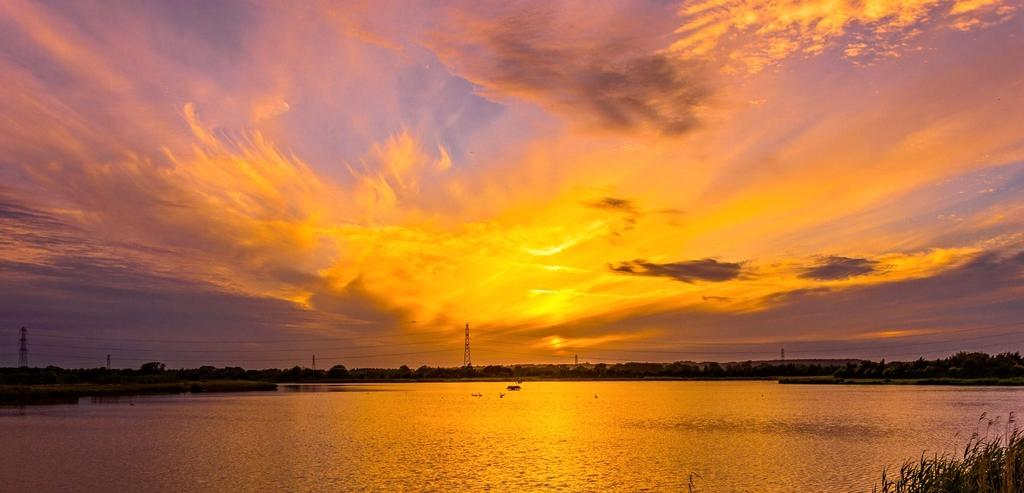What is the primary element present in the image? There is water in the image. What type of natural elements can be seen in the image? There are trees in the image. What man-made structures are visible in the image? There are poles and a building in the image. How would you describe the weather in the image? The sky is cloudy with sunlight in the image, suggesting a mix of cloud cover and sunshine. What type of advertisement can be seen on the neck of the person in the image? There is no person or advertisement present in the image; it features water, trees, poles, and a building. 